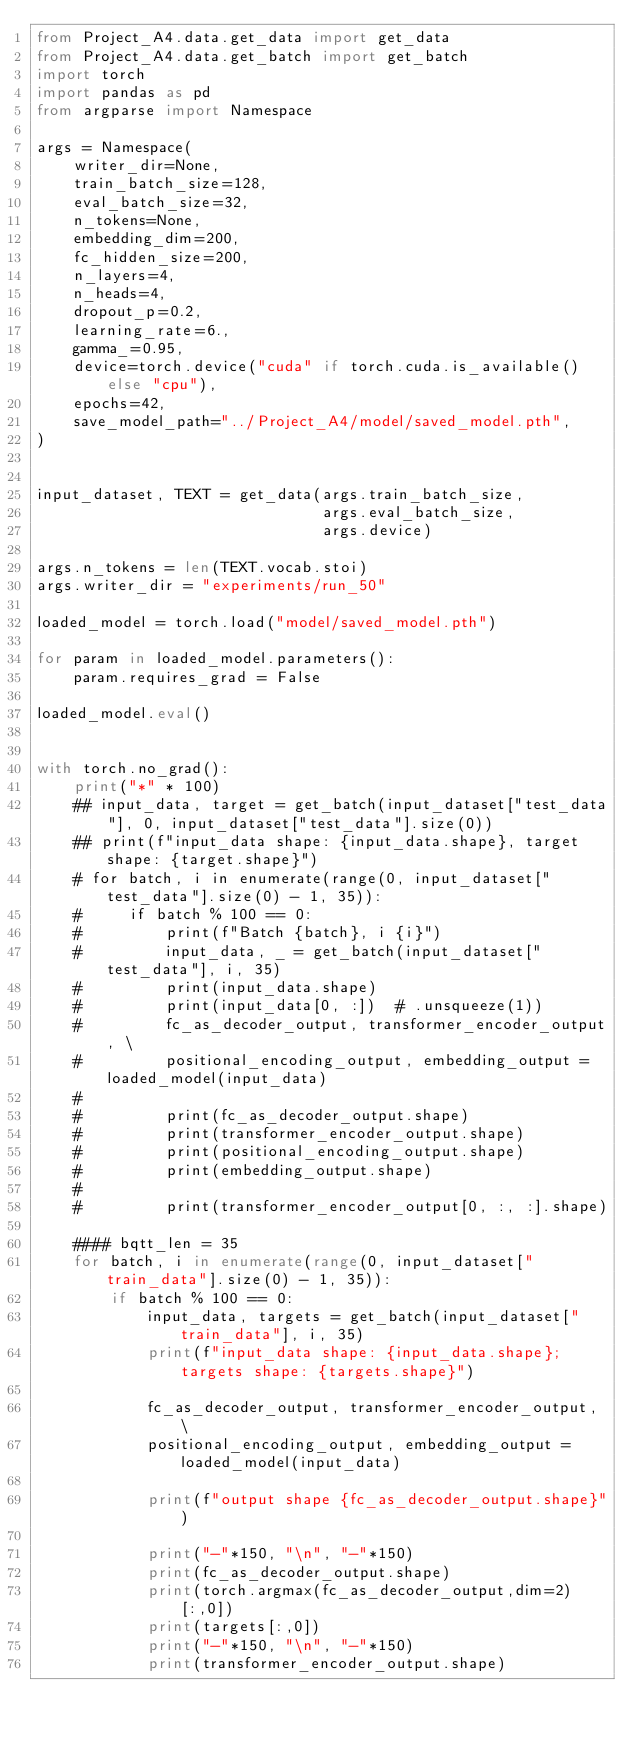Convert code to text. <code><loc_0><loc_0><loc_500><loc_500><_Python_>from Project_A4.data.get_data import get_data
from Project_A4.data.get_batch import get_batch
import torch
import pandas as pd
from argparse import Namespace

args = Namespace(
    writer_dir=None,
    train_batch_size=128,
    eval_batch_size=32,
    n_tokens=None,
    embedding_dim=200,
    fc_hidden_size=200,
    n_layers=4,
    n_heads=4,
    dropout_p=0.2,
    learning_rate=6.,
    gamma_=0.95,
    device=torch.device("cuda" if torch.cuda.is_available() else "cpu"),
    epochs=42,
    save_model_path="../Project_A4/model/saved_model.pth",
)


input_dataset, TEXT = get_data(args.train_batch_size,
                               args.eval_batch_size,
                               args.device)

args.n_tokens = len(TEXT.vocab.stoi)
args.writer_dir = "experiments/run_50"

loaded_model = torch.load("model/saved_model.pth")

for param in loaded_model.parameters():
    param.requires_grad = False

loaded_model.eval()


with torch.no_grad():
    print("*" * 100)
    ## input_data, target = get_batch(input_dataset["test_data"], 0, input_dataset["test_data"].size(0))
    ## print(f"input_data shape: {input_data.shape}, target shape: {target.shape}")
    # for batch, i in enumerate(range(0, input_dataset["test_data"].size(0) - 1, 35)):
    #     if batch % 100 == 0:
    #         print(f"Batch {batch}, i {i}")
    #         input_data, _ = get_batch(input_dataset["test_data"], i, 35)
    #         print(input_data.shape)
    #         print(input_data[0, :])  # .unsqueeze(1))
    #         fc_as_decoder_output, transformer_encoder_output, \
    #         positional_encoding_output, embedding_output = loaded_model(input_data)
    #
    #         print(fc_as_decoder_output.shape)
    #         print(transformer_encoder_output.shape)
    #         print(positional_encoding_output.shape)
    #         print(embedding_output.shape)
    #
    #         print(transformer_encoder_output[0, :, :].shape)

    #### bqtt_len = 35
    for batch, i in enumerate(range(0, input_dataset["train_data"].size(0) - 1, 35)):
        if batch % 100 == 0:
            input_data, targets = get_batch(input_dataset["train_data"], i, 35)
            print(f"input_data shape: {input_data.shape}; targets shape: {targets.shape}")

            fc_as_decoder_output, transformer_encoder_output, \
            positional_encoding_output, embedding_output = loaded_model(input_data)

            print(f"output shape {fc_as_decoder_output.shape}")

            print("-"*150, "\n", "-"*150)
            print(fc_as_decoder_output.shape)
            print(torch.argmax(fc_as_decoder_output,dim=2)[:,0])
            print(targets[:,0])
            print("-"*150, "\n", "-"*150)
            print(transformer_encoder_output.shape)

            


</code> 